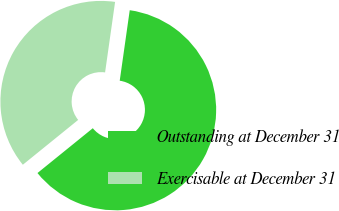Convert chart to OTSL. <chart><loc_0><loc_0><loc_500><loc_500><pie_chart><fcel>Outstanding at December 31<fcel>Exercisable at December 31<nl><fcel>61.92%<fcel>38.08%<nl></chart> 